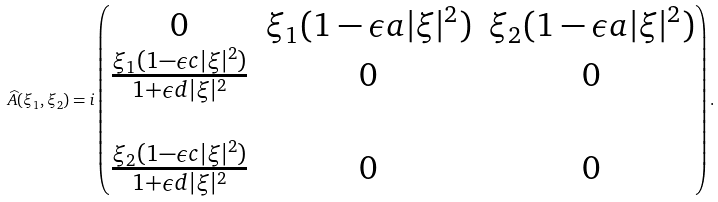Convert formula to latex. <formula><loc_0><loc_0><loc_500><loc_500>\widehat { A } ( \xi _ { 1 } , \xi _ { 2 } ) = i \begin{pmatrix} 0 & \xi _ { 1 } ( 1 - \epsilon a | \xi | ^ { 2 } ) & \xi _ { 2 } ( 1 - \epsilon a | \xi | ^ { 2 } ) \\ \frac { \xi _ { 1 } ( 1 - \epsilon c | \xi | ^ { 2 } ) } { 1 + \epsilon d | \xi | ^ { 2 } } & 0 & 0 \\ \\ \frac { \xi _ { 2 } ( 1 - \epsilon c | \xi | ^ { 2 } ) } { 1 + \epsilon d | \xi | ^ { 2 } } & 0 & 0 \end{pmatrix} .</formula> 